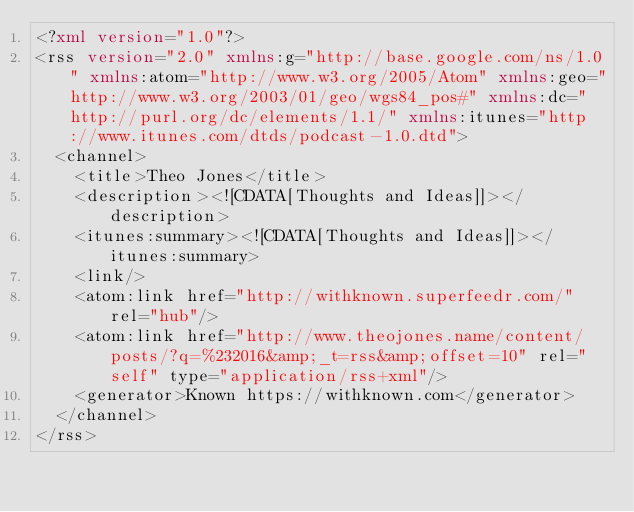Convert code to text. <code><loc_0><loc_0><loc_500><loc_500><_XML_><?xml version="1.0"?>
<rss version="2.0" xmlns:g="http://base.google.com/ns/1.0" xmlns:atom="http://www.w3.org/2005/Atom" xmlns:geo="http://www.w3.org/2003/01/geo/wgs84_pos#" xmlns:dc="http://purl.org/dc/elements/1.1/" xmlns:itunes="http://www.itunes.com/dtds/podcast-1.0.dtd">
  <channel>
    <title>Theo Jones</title>
    <description><![CDATA[Thoughts and Ideas]]></description>
    <itunes:summary><![CDATA[Thoughts and Ideas]]></itunes:summary>
    <link/>
    <atom:link href="http://withknown.superfeedr.com/" rel="hub"/>
    <atom:link href="http://www.theojones.name/content/posts/?q=%232016&amp;_t=rss&amp;offset=10" rel="self" type="application/rss+xml"/>
    <generator>Known https://withknown.com</generator>
  </channel>
</rss>
</code> 